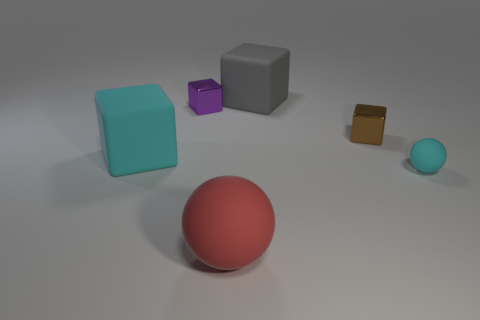Is there another small shiny object that has the same shape as the small brown thing?
Keep it short and to the point. Yes. There is a large rubber sphere; what number of small metallic cubes are behind it?
Your response must be concise. 2. There is a large thing that is behind the rubber cube that is on the left side of the gray block; what is its material?
Keep it short and to the point. Rubber. There is a red thing that is the same size as the gray matte thing; what material is it?
Your response must be concise. Rubber. Is there a gray ball of the same size as the gray cube?
Give a very brief answer. No. What is the color of the rubber sphere that is left of the cyan sphere?
Your answer should be compact. Red. There is a cyan rubber object that is on the left side of the brown block; is there a small metal cube that is on the left side of it?
Your answer should be compact. No. What number of other things are the same color as the tiny rubber thing?
Your answer should be very brief. 1. There is a rubber cube right of the big cyan thing; is its size the same as the cyan matte object in front of the big cyan rubber object?
Make the answer very short. No. What is the size of the cyan object in front of the cyan thing that is on the left side of the tiny cyan rubber sphere?
Offer a very short reply. Small. 